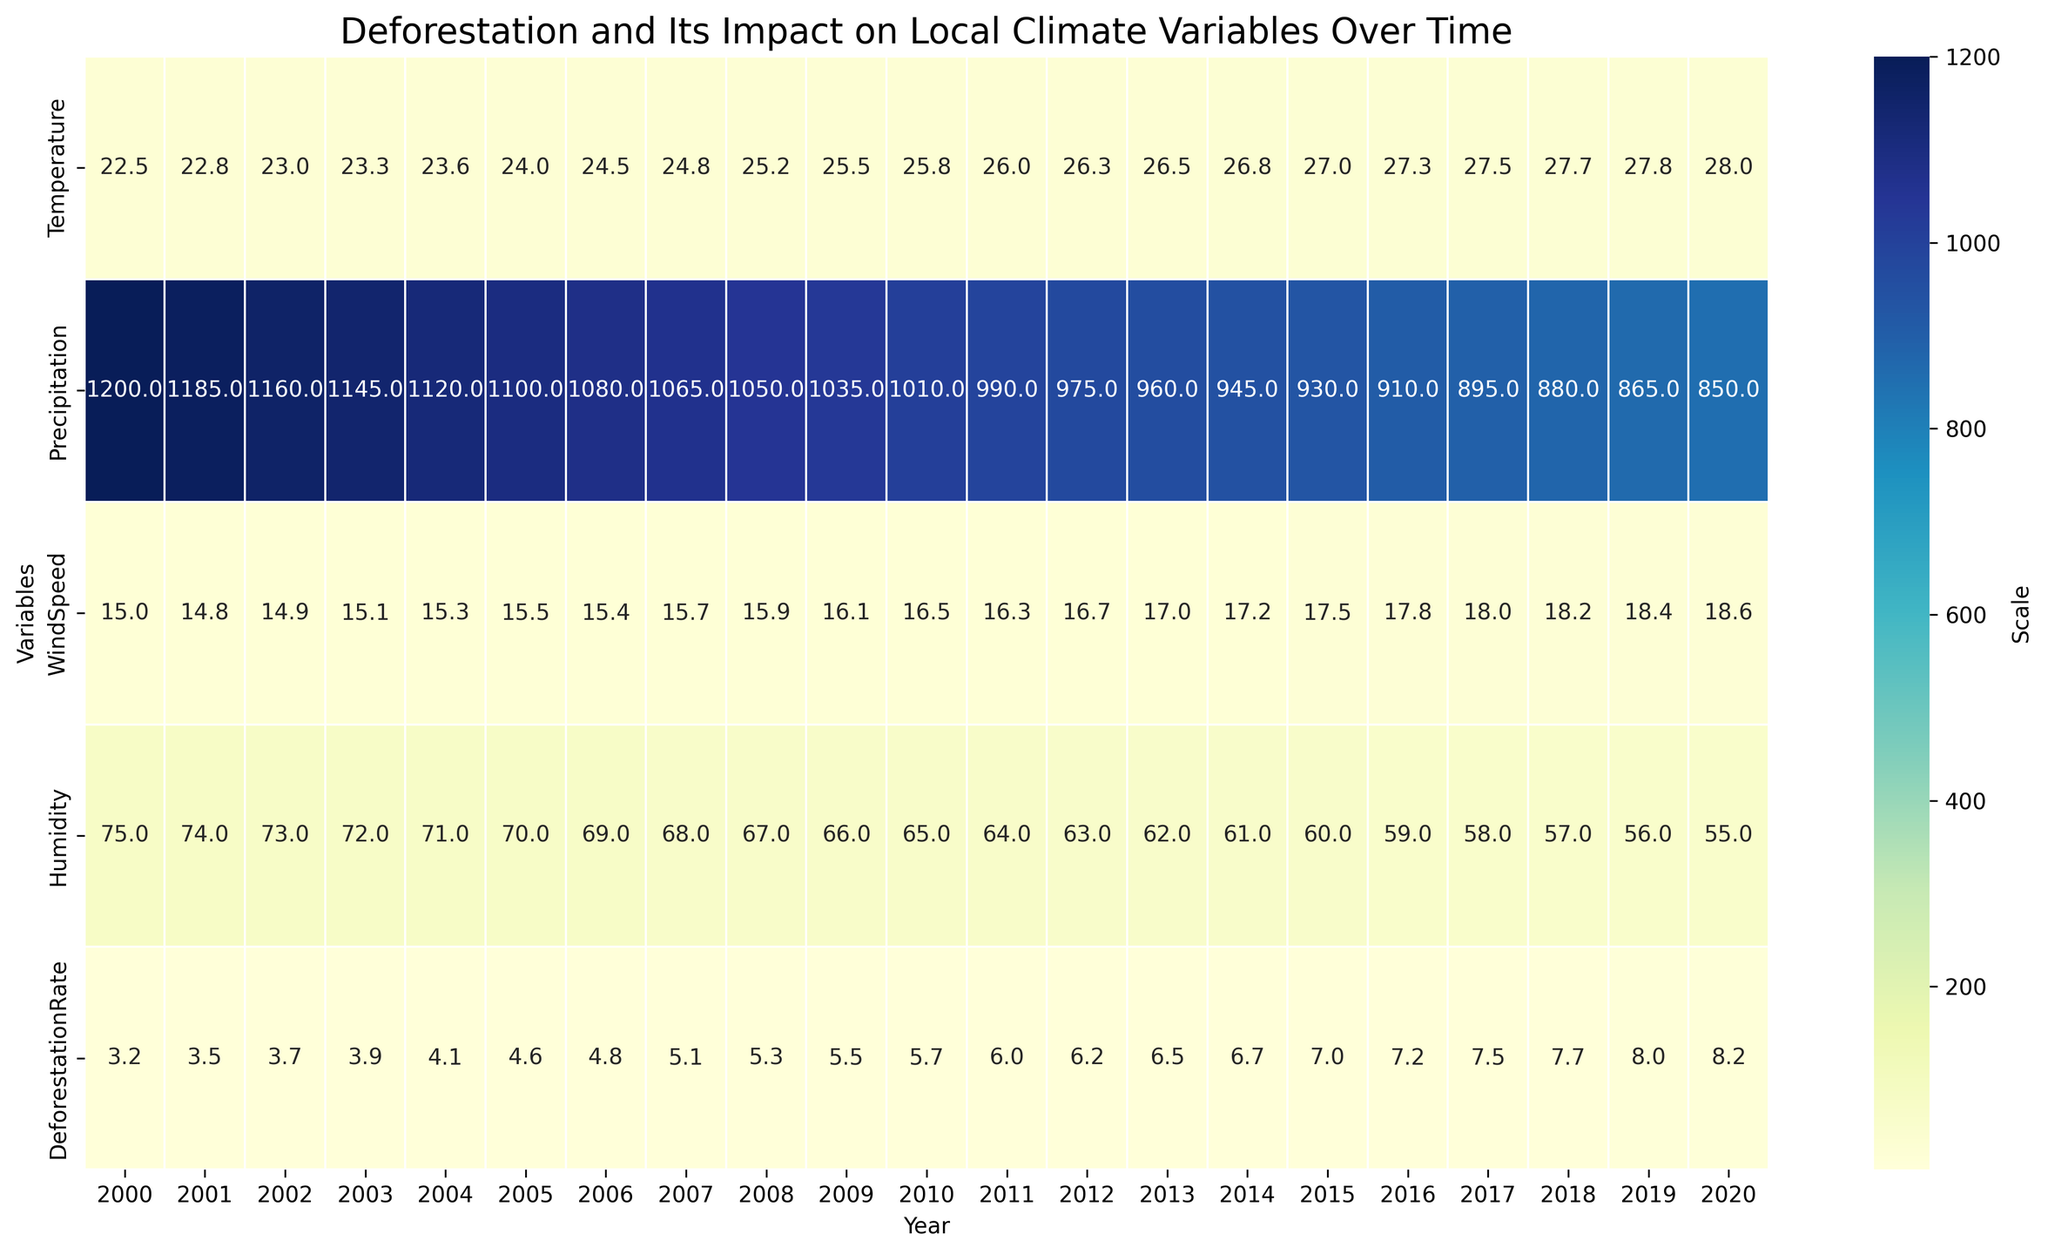What is the deforestation rate in 2010? To find the deforestation rate in 2010, locate the column for the year 2010 and read off the value at the intersection with the deforestation rate row.
Answer: 5.7 Which year had the highest temperature? To determine the year with the highest temperature, look across the temperature row to identify the maximum value and then check the corresponding year at the top of the figure.
Answer: 2020 What is the difference in precipitation levels between the years 2000 and 2020? Find the precipitation values for the years 2000 and 2020 and subtract the value for 2020 from the value for 2000: 1200 - 850 = 350.
Answer: 350 How has the average humidity changed from 2000 to 2020? Find the humidity values for each year from 2000 to 2020, sum them up, and then divide by the total number of years. Compare it with the initial year (70) and the final year (55) to understand the change.
Answer: -15 Compare the temperature between 2000 and 2020. Which year had a higher temperature and by how much? Locate the temperature values for the years 2000 and 2020, then subtract the 2000 value from the 2020 value: 28.0 - 22.5 = 5.5.
Answer: 2020, by 5.5 Identify the trend in wind speed over the years. Has it generally increased, decreased, or remained stable? Visually inspect the wind speed values from 2000 to 2020. The values show a slight increase over time, from 15.0 to 18.6.
Answer: Increased Which variable shows the most significant decrease over time? Examine all variables across the years to identify the one with the highest decrease. Precipitation shows the most significant decrease from 1200 to 850.
Answer: Precipitation Calculate the average deforestation rate for the years 2015 to 2020. Sum the deforestation rates for the years 2015 (7.0), 2016 (7.2), 2017 (7.5), 2018 (7.7), 2019 (8.0), 2020 (8.2), and divide by the number of years: (7.0 + 7.2 + 7.5 + 7.7 + 8.0 + 8.2) / 6 = 7.6.
Answer: 7.6 Is there an apparent correlation between deforestation rate and temperature increase? Visually inspect the overall trend for temperature and deforestation rate from 2000 to 2020. Both variables show an increasing trend over time, suggesting a possible correlation.
Answer: Yes Which year had the lowest humidity, and what was the corresponding deforestation rate that year? Locate the lowest value in the humidity row and check the corresponding year and deforestation rate. The lowest humidity is in 2020, with a deforestation rate of 8.2.
Answer: 2020, 8.2 